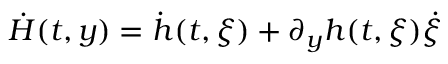Convert formula to latex. <formula><loc_0><loc_0><loc_500><loc_500>\dot { H } ( t , y ) = \dot { h } ( t , \xi ) + \partial _ { y } h ( t , \xi ) \dot { \xi }</formula> 